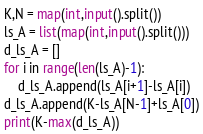<code> <loc_0><loc_0><loc_500><loc_500><_Python_>K,N = map(int,input().split())
ls_A = list(map(int,input().split()))
d_ls_A = []
for i in range(len(ls_A)-1):
    d_ls_A.append(ls_A[i+1]-ls_A[i])
d_ls_A.append(K-ls_A[N-1]+ls_A[0])
print(K-max(d_ls_A))</code> 